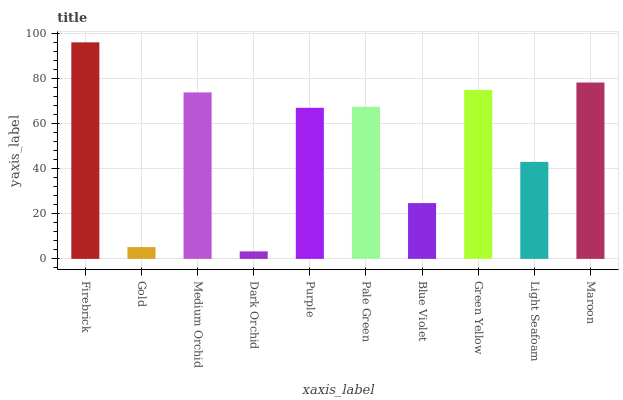Is Dark Orchid the minimum?
Answer yes or no. Yes. Is Firebrick the maximum?
Answer yes or no. Yes. Is Gold the minimum?
Answer yes or no. No. Is Gold the maximum?
Answer yes or no. No. Is Firebrick greater than Gold?
Answer yes or no. Yes. Is Gold less than Firebrick?
Answer yes or no. Yes. Is Gold greater than Firebrick?
Answer yes or no. No. Is Firebrick less than Gold?
Answer yes or no. No. Is Pale Green the high median?
Answer yes or no. Yes. Is Purple the low median?
Answer yes or no. Yes. Is Light Seafoam the high median?
Answer yes or no. No. Is Pale Green the low median?
Answer yes or no. No. 